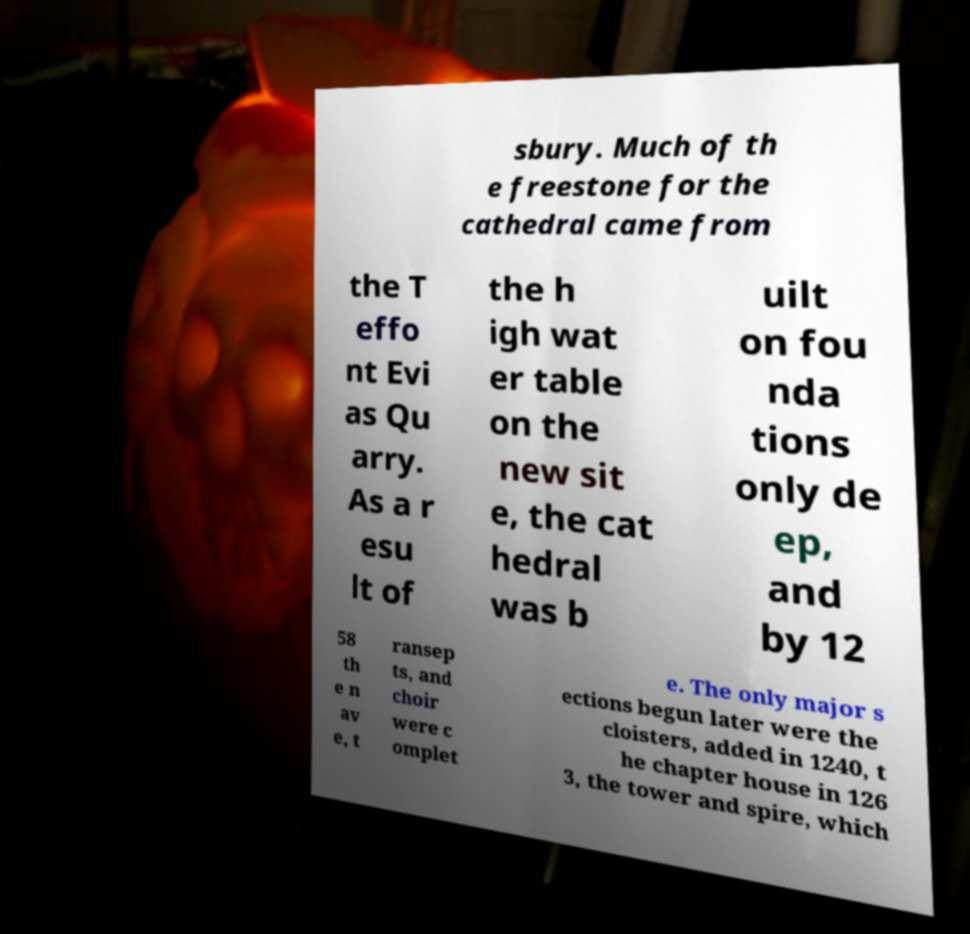Could you extract and type out the text from this image? sbury. Much of th e freestone for the cathedral came from the T effo nt Evi as Qu arry. As a r esu lt of the h igh wat er table on the new sit e, the cat hedral was b uilt on fou nda tions only de ep, and by 12 58 th e n av e, t ransep ts, and choir were c omplet e. The only major s ections begun later were the cloisters, added in 1240, t he chapter house in 126 3, the tower and spire, which 